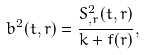<formula> <loc_0><loc_0><loc_500><loc_500>b ^ { 2 } ( t , r ) = \frac { S ^ { 2 } _ { , r } ( t , r ) } { k + f ( r ) } ,</formula> 